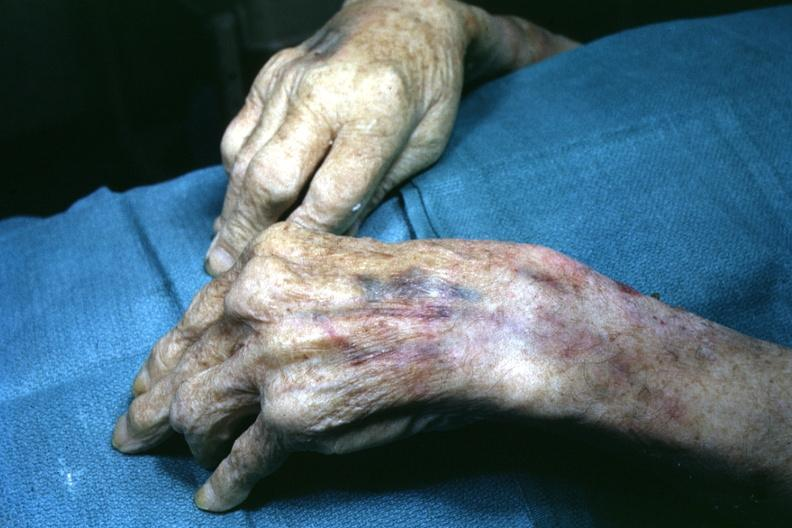s gout present?
Answer the question using a single word or phrase. Yes 